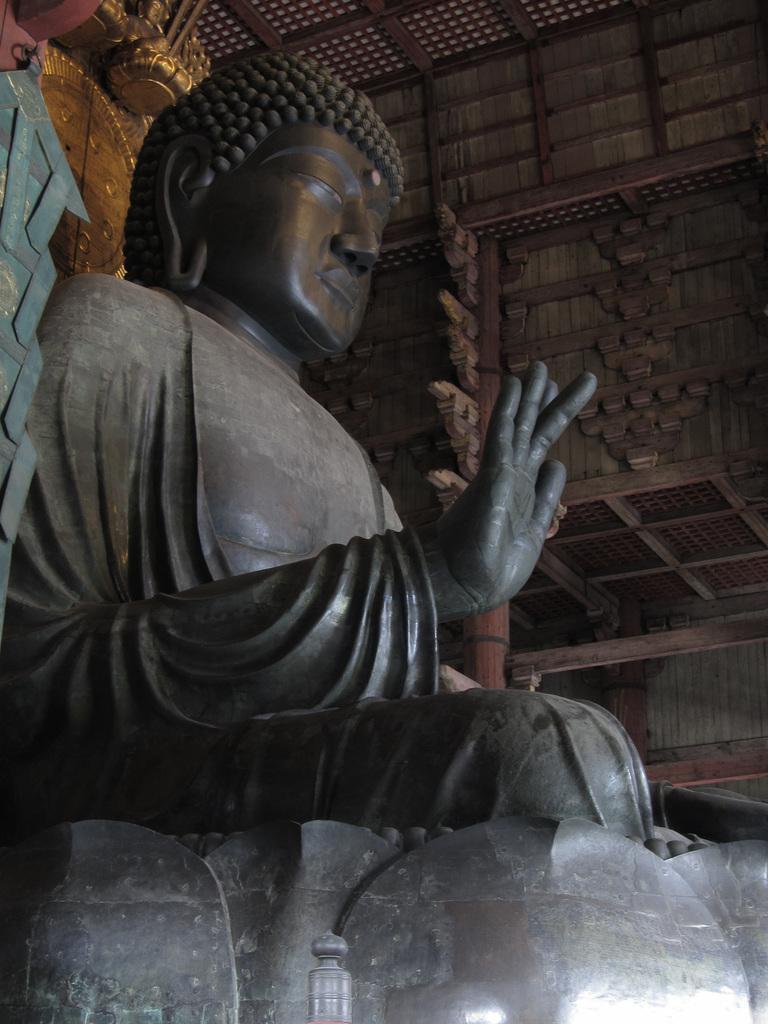Can you describe this image briefly? In this image it looks like inside of the building. And there is a sculpture. And at the back there is a wooden stick with design. 